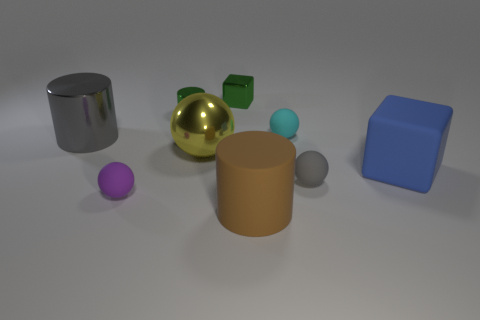Subtract all brown matte cylinders. How many cylinders are left? 2 Add 1 tiny green shiny objects. How many objects exist? 10 Subtract 1 cylinders. How many cylinders are left? 2 Subtract all purple balls. How many balls are left? 3 Subtract all yellow cylinders. Subtract all green balls. How many cylinders are left? 3 Add 3 big cylinders. How many big cylinders exist? 5 Subtract 0 blue cylinders. How many objects are left? 9 Subtract all cylinders. How many objects are left? 6 Subtract all small metal cylinders. Subtract all matte spheres. How many objects are left? 5 Add 1 cyan matte objects. How many cyan matte objects are left? 2 